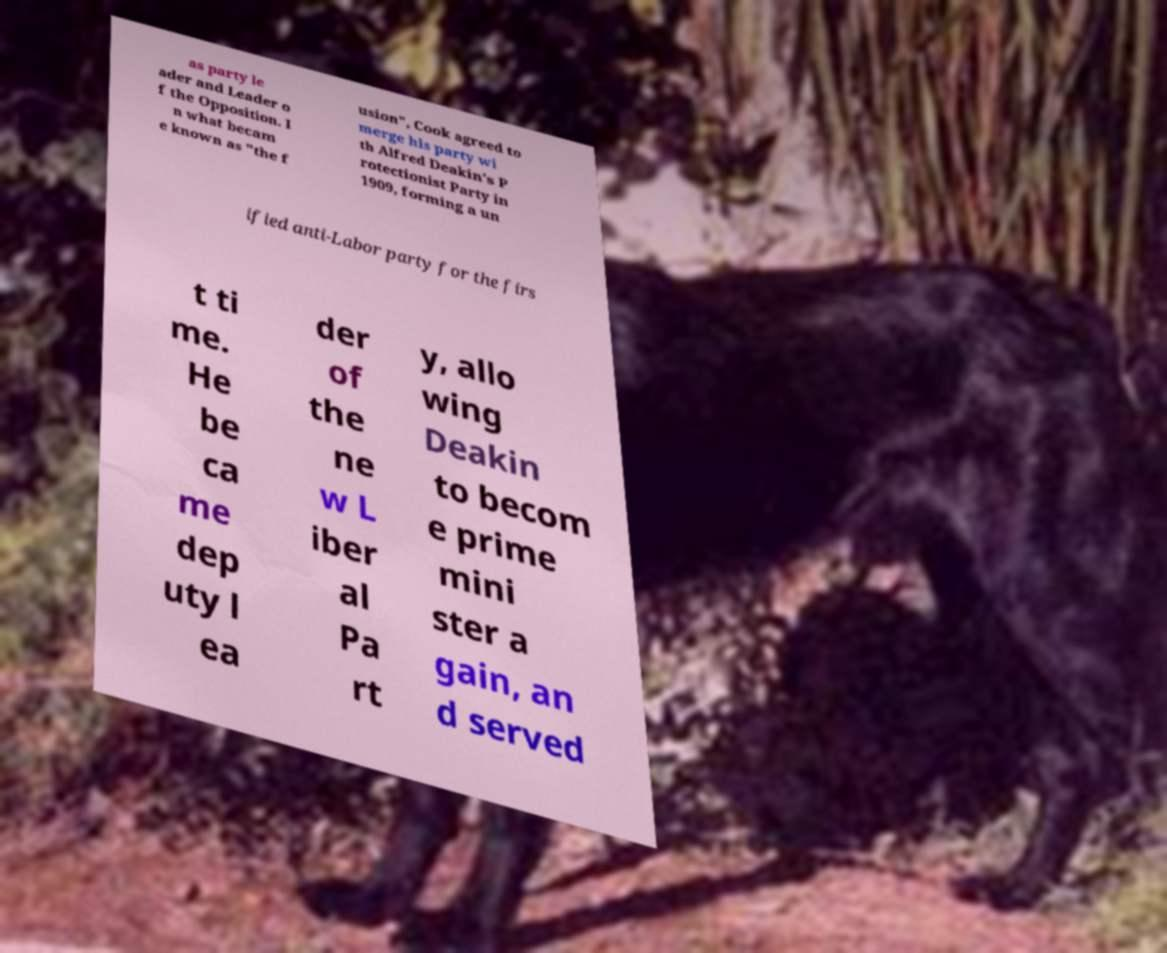For documentation purposes, I need the text within this image transcribed. Could you provide that? as party le ader and Leader o f the Opposition. I n what becam e known as "the f usion", Cook agreed to merge his party wi th Alfred Deakin's P rotectionist Party in 1909, forming a un ified anti-Labor party for the firs t ti me. He be ca me dep uty l ea der of the ne w L iber al Pa rt y, allo wing Deakin to becom e prime mini ster a gain, an d served 